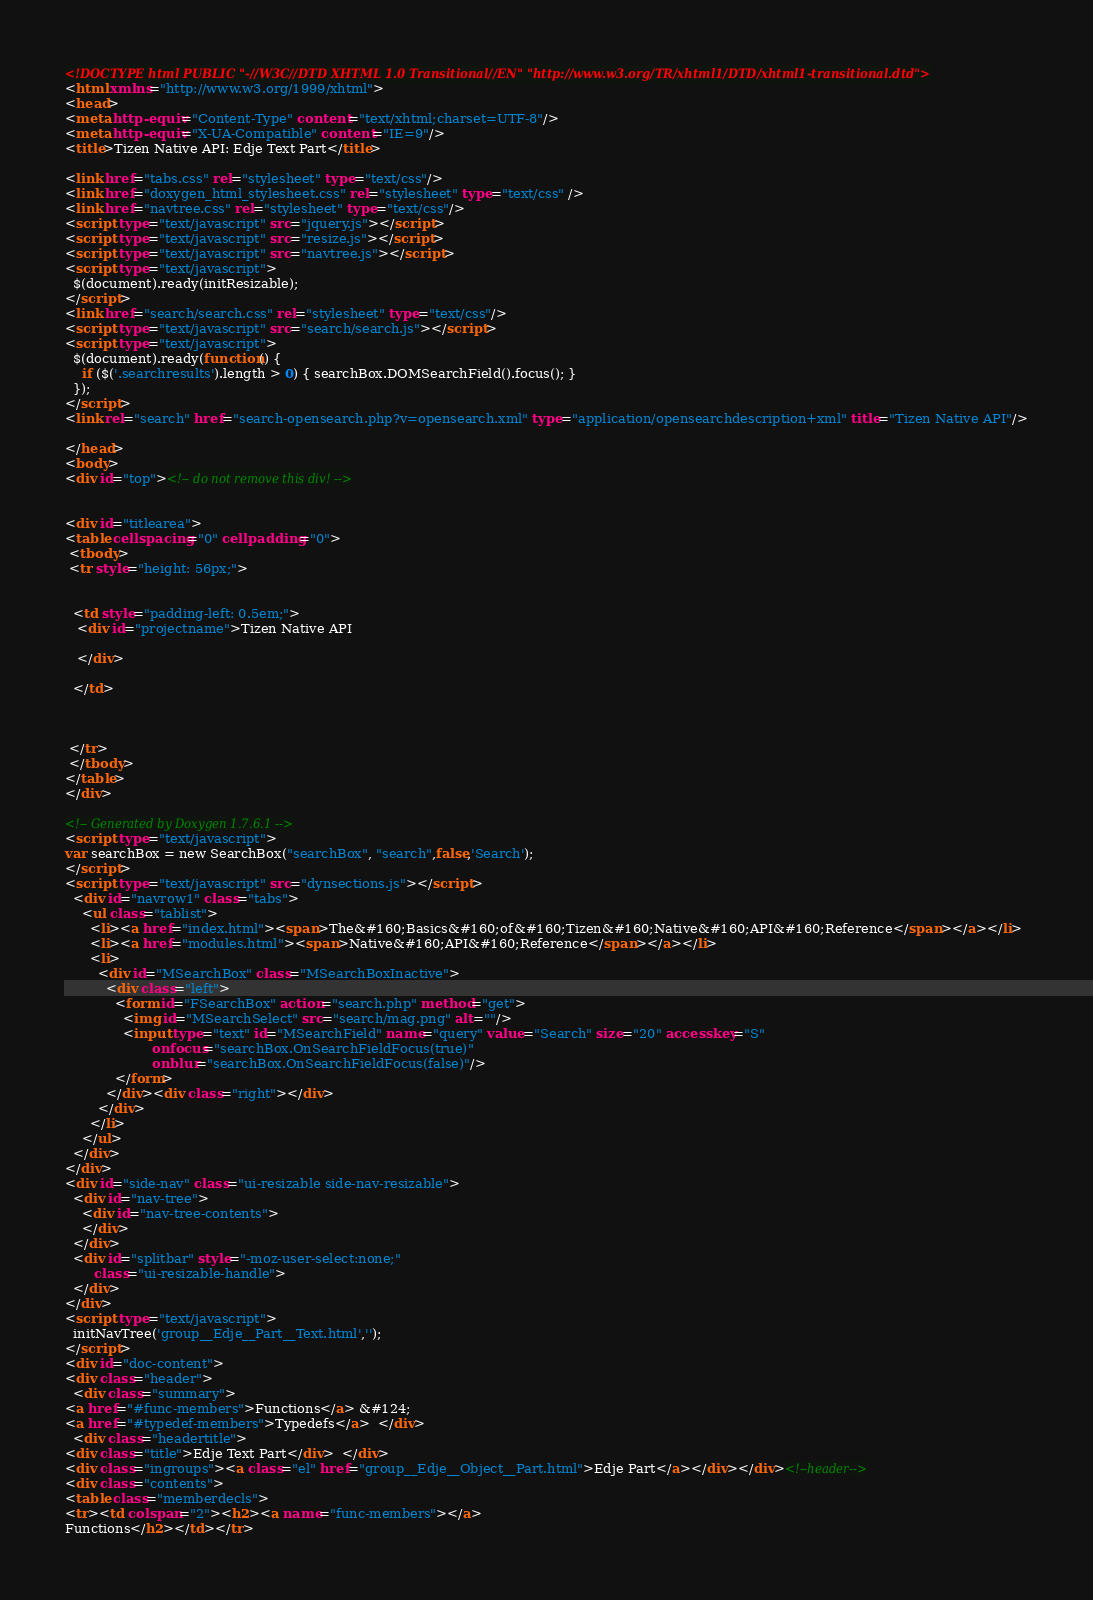Convert code to text. <code><loc_0><loc_0><loc_500><loc_500><_HTML_><!DOCTYPE html PUBLIC "-//W3C//DTD XHTML 1.0 Transitional//EN" "http://www.w3.org/TR/xhtml1/DTD/xhtml1-transitional.dtd">
<html xmlns="http://www.w3.org/1999/xhtml">
<head>
<meta http-equiv="Content-Type" content="text/xhtml;charset=UTF-8"/>
<meta http-equiv="X-UA-Compatible" content="IE=9"/>
<title>Tizen Native API: Edje Text Part</title>

<link href="tabs.css" rel="stylesheet" type="text/css"/>
<link href="doxygen_html_stylesheet.css" rel="stylesheet" type="text/css" />
<link href="navtree.css" rel="stylesheet" type="text/css"/>
<script type="text/javascript" src="jquery.js"></script>
<script type="text/javascript" src="resize.js"></script>
<script type="text/javascript" src="navtree.js"></script>
<script type="text/javascript">
  $(document).ready(initResizable);
</script>
<link href="search/search.css" rel="stylesheet" type="text/css"/>
<script type="text/javascript" src="search/search.js"></script>
<script type="text/javascript">
  $(document).ready(function() {
    if ($('.searchresults').length > 0) { searchBox.DOMSearchField().focus(); }
  });
</script>
<link rel="search" href="search-opensearch.php?v=opensearch.xml" type="application/opensearchdescription+xml" title="Tizen Native API"/>

</head>
<body>
<div id="top"><!-- do not remove this div! -->


<div id="titlearea">
<table cellspacing="0" cellpadding="0">
 <tbody>
 <tr style="height: 56px;">
  
  
  <td style="padding-left: 0.5em;">
   <div id="projectname">Tizen Native API
   
   </div>
   
  </td>
  
  
  
 </tr>
 </tbody>
</table>
</div>

<!-- Generated by Doxygen 1.7.6.1 -->
<script type="text/javascript">
var searchBox = new SearchBox("searchBox", "search",false,'Search');
</script>
<script type="text/javascript" src="dynsections.js"></script>
  <div id="navrow1" class="tabs">
    <ul class="tablist">
      <li><a href="index.html"><span>The&#160;Basics&#160;of&#160;Tizen&#160;Native&#160;API&#160;Reference</span></a></li>
      <li><a href="modules.html"><span>Native&#160;API&#160;Reference</span></a></li>
      <li>
        <div id="MSearchBox" class="MSearchBoxInactive">
          <div class="left">
            <form id="FSearchBox" action="search.php" method="get">
              <img id="MSearchSelect" src="search/mag.png" alt=""/>
              <input type="text" id="MSearchField" name="query" value="Search" size="20" accesskey="S" 
                     onfocus="searchBox.OnSearchFieldFocus(true)" 
                     onblur="searchBox.OnSearchFieldFocus(false)"/>
            </form>
          </div><div class="right"></div>
        </div>
      </li>
    </ul>
  </div>
</div>
<div id="side-nav" class="ui-resizable side-nav-resizable">
  <div id="nav-tree">
    <div id="nav-tree-contents">
    </div>
  </div>
  <div id="splitbar" style="-moz-user-select:none;" 
       class="ui-resizable-handle">
  </div>
</div>
<script type="text/javascript">
  initNavTree('group__Edje__Part__Text.html','');
</script>
<div id="doc-content">
<div class="header">
  <div class="summary">
<a href="#func-members">Functions</a> &#124;
<a href="#typedef-members">Typedefs</a>  </div>
  <div class="headertitle">
<div class="title">Edje Text Part</div>  </div>
<div class="ingroups"><a class="el" href="group__Edje__Object__Part.html">Edje Part</a></div></div><!--header-->
<div class="contents">
<table class="memberdecls">
<tr><td colspan="2"><h2><a name="func-members"></a>
Functions</h2></td></tr></code> 